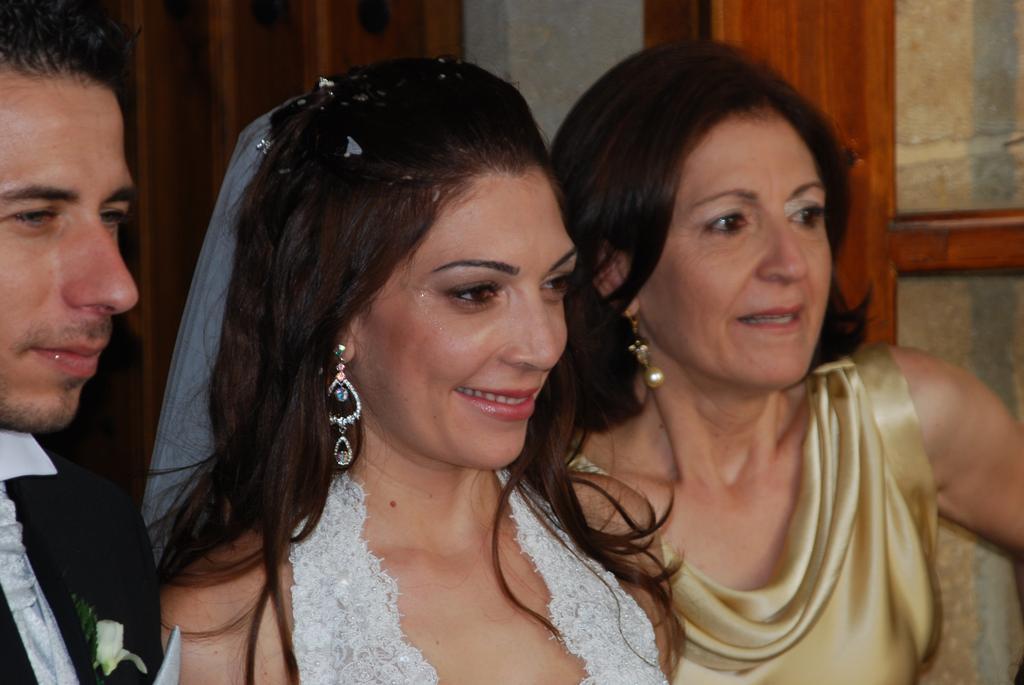How would you summarize this image in a sentence or two? In front of the picture, we see three people. Out of them, two are women and one is a man. The woman in the white dress is smiling. Beside her, the woman in the gold color dress is also smiling. Behind them, we see a white wall and a cupboard in brown color. 